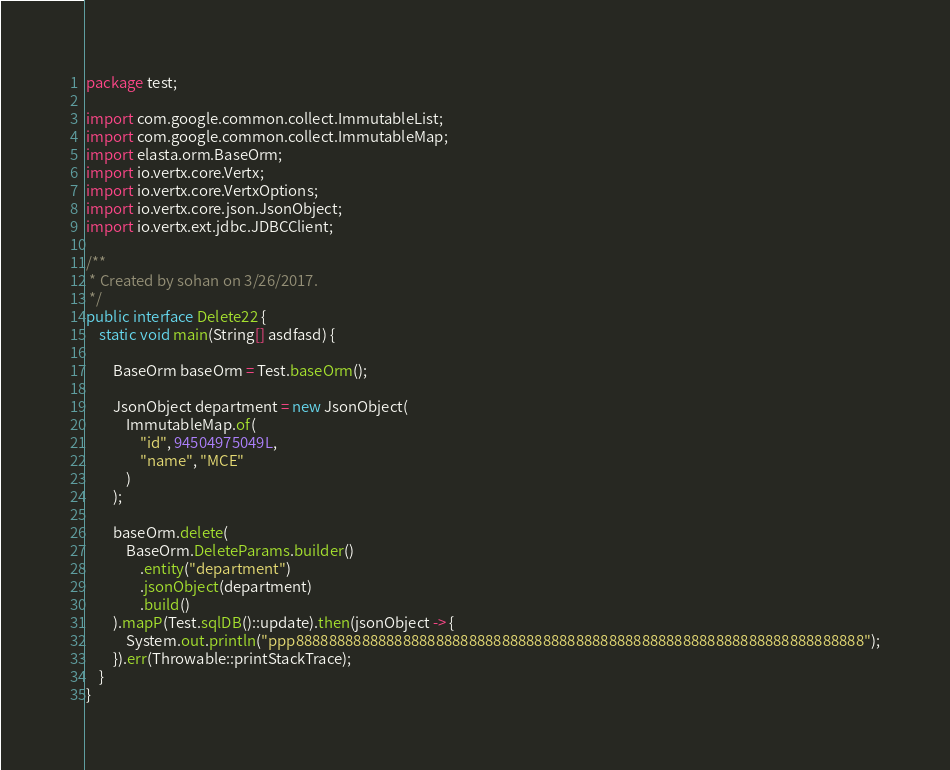Convert code to text. <code><loc_0><loc_0><loc_500><loc_500><_Java_>package test;

import com.google.common.collect.ImmutableList;
import com.google.common.collect.ImmutableMap;
import elasta.orm.BaseOrm;
import io.vertx.core.Vertx;
import io.vertx.core.VertxOptions;
import io.vertx.core.json.JsonObject;
import io.vertx.ext.jdbc.JDBCClient;

/**
 * Created by sohan on 3/26/2017.
 */
public interface Delete22 {
    static void main(String[] asdfasd) {

        BaseOrm baseOrm = Test.baseOrm();

        JsonObject department = new JsonObject(
            ImmutableMap.of(
                "id", 94504975049L,
                "name", "MCE"
            )
        );

        baseOrm.delete(
            BaseOrm.DeleteParams.builder()
                .entity("department")
                .jsonObject(department)
                .build()
        ).mapP(Test.sqlDB()::update).then(jsonObject -> {
            System.out.println("ppp888888888888888888888888888888888888888888888888888888888888888888888");
        }).err(Throwable::printStackTrace);
    }
}
</code> 